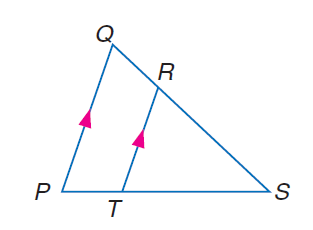Answer the mathemtical geometry problem and directly provide the correct option letter.
Question: If R T = 16, Q P = 24, and S T = 9, find P S.
Choices: A: 6 B: 9 C: 12 D: 13.5 D 